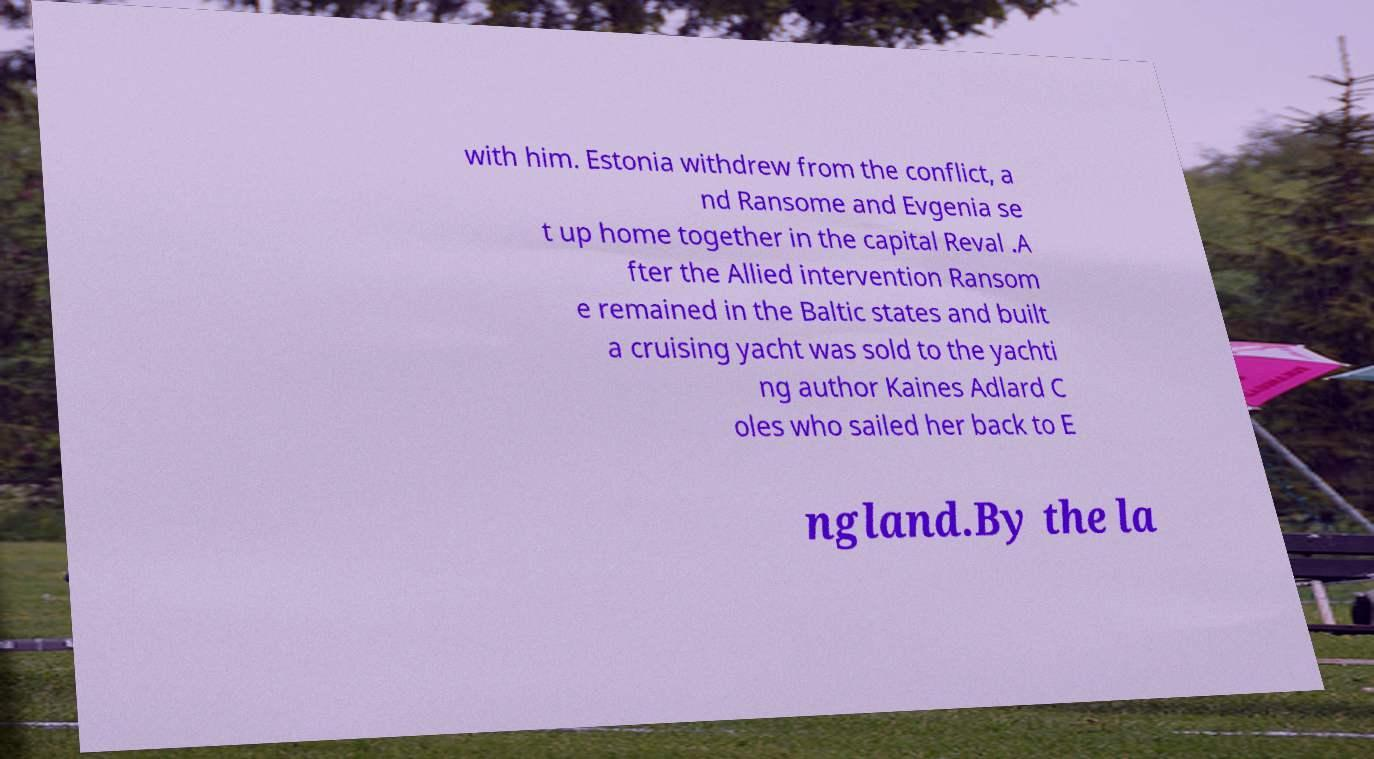There's text embedded in this image that I need extracted. Can you transcribe it verbatim? with him. Estonia withdrew from the conflict, a nd Ransome and Evgenia se t up home together in the capital Reval .A fter the Allied intervention Ransom e remained in the Baltic states and built a cruising yacht was sold to the yachti ng author Kaines Adlard C oles who sailed her back to E ngland.By the la 